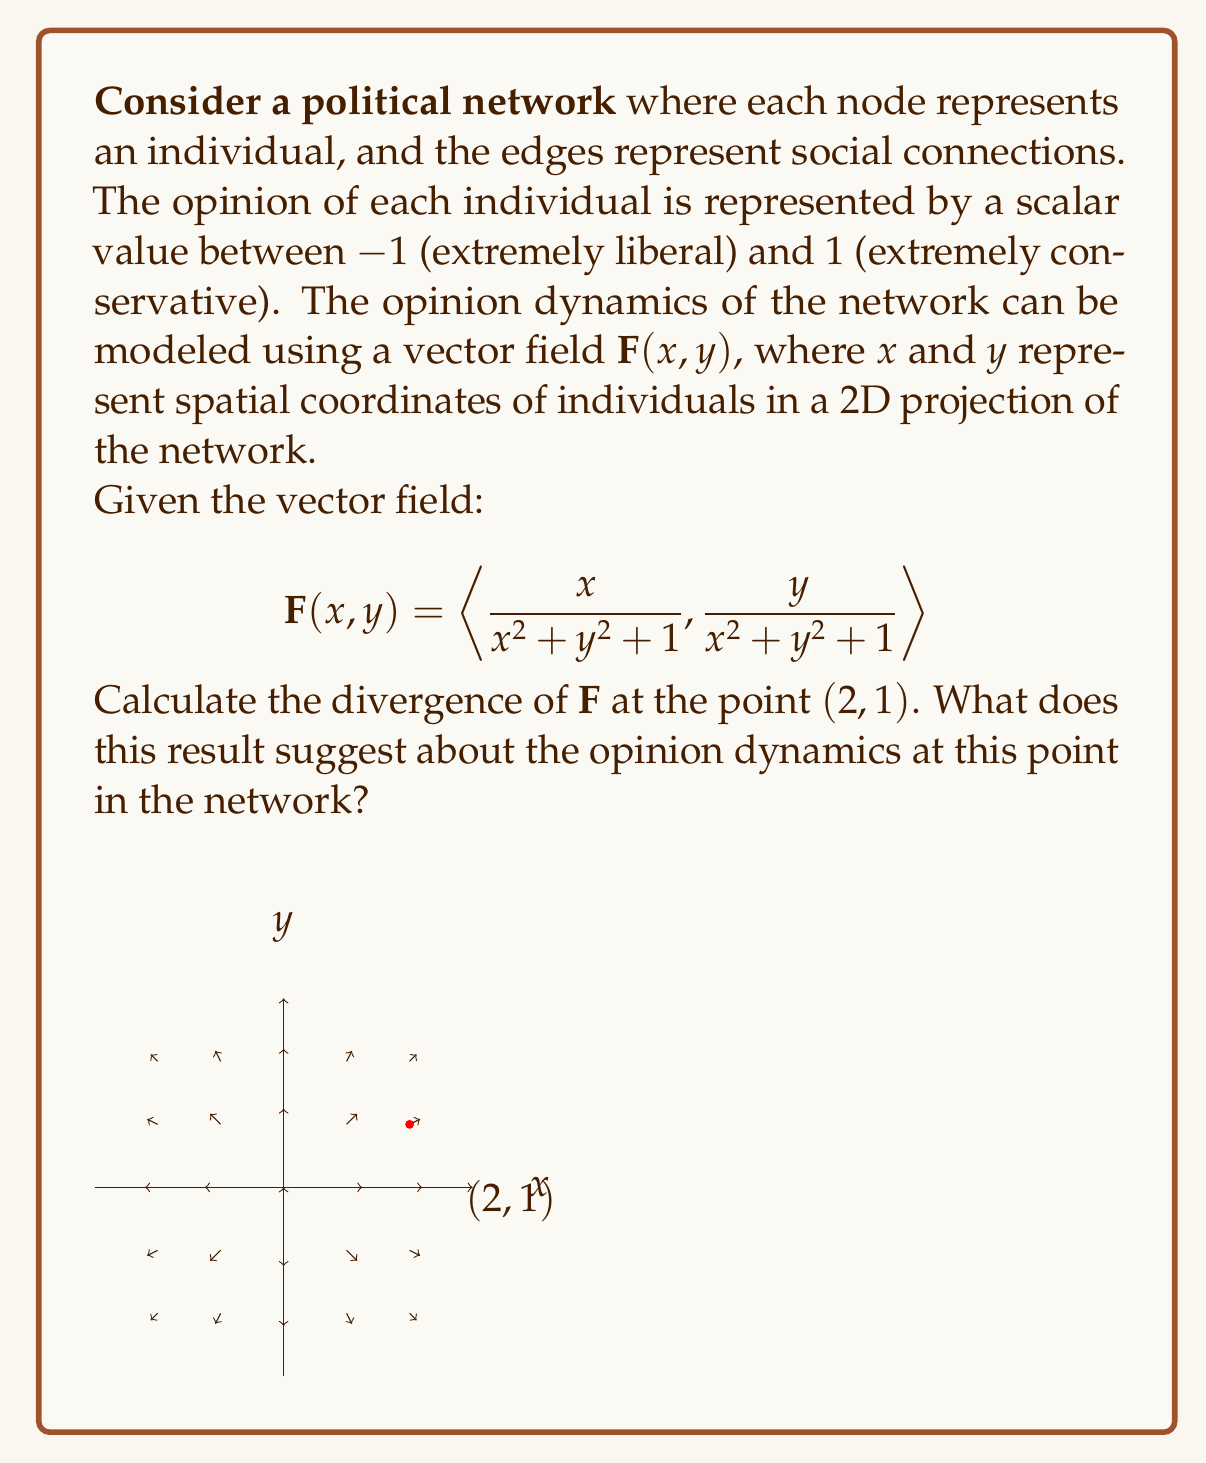Provide a solution to this math problem. To solve this problem, we need to follow these steps:

1) The divergence of a vector field $\mathbf{F}(x, y) = \langle P(x,y), Q(x,y) \rangle$ is given by:

   $$\text{div}\mathbf{F} = \nabla \cdot \mathbf{F} = \frac{\partial P}{\partial x} + \frac{\partial Q}{\partial y}$$

2) In our case, 
   $$P(x,y) = \frac{x}{x^2 + y^2 + 1}$$ 
   $$Q(x,y) = \frac{y}{x^2 + y^2 + 1}$$

3) We need to calculate $\frac{\partial P}{\partial x}$ and $\frac{\partial Q}{\partial y}$:

   $$\frac{\partial P}{\partial x} = \frac{(x^2 + y^2 + 1) - x(2x)}{(x^2 + y^2 + 1)^2} = \frac{y^2 + 1 - x^2}{(x^2 + y^2 + 1)^2}$$

   $$\frac{\partial Q}{\partial y} = \frac{(x^2 + y^2 + 1) - y(2y)}{(x^2 + y^2 + 1)^2} = \frac{x^2 + 1 - y^2}{(x^2 + y^2 + 1)^2}$$

4) The divergence is the sum of these partial derivatives:

   $$\text{div}\mathbf{F} = \frac{y^2 + 1 - x^2}{(x^2 + y^2 + 1)^2} + \frac{x^2 + 1 - y^2}{(x^2 + y^2 + 1)^2} = \frac{2}{(x^2 + y^2 + 1)^2}$$

5) At the point (2, 1), we can substitute these values:

   $$\text{div}\mathbf{F}(2,1) = \frac{2}{(2^2 + 1^2 + 1)^2} = \frac{2}{6^2} = \frac{2}{36} = \frac{1}{18} \approx 0.0556$$

6) Interpretation: The positive divergence at (2, 1) suggests that this point is a source in the vector field. In the context of opinion dynamics, this indicates that opinions are diverging or spreading out from this point in the network. It could represent an influential individual or a group that is actively spreading their political views, causing nearby individuals to adopt more extreme positions.
Answer: $\frac{1}{18}$; opinion divergence/spreading at (2,1) 